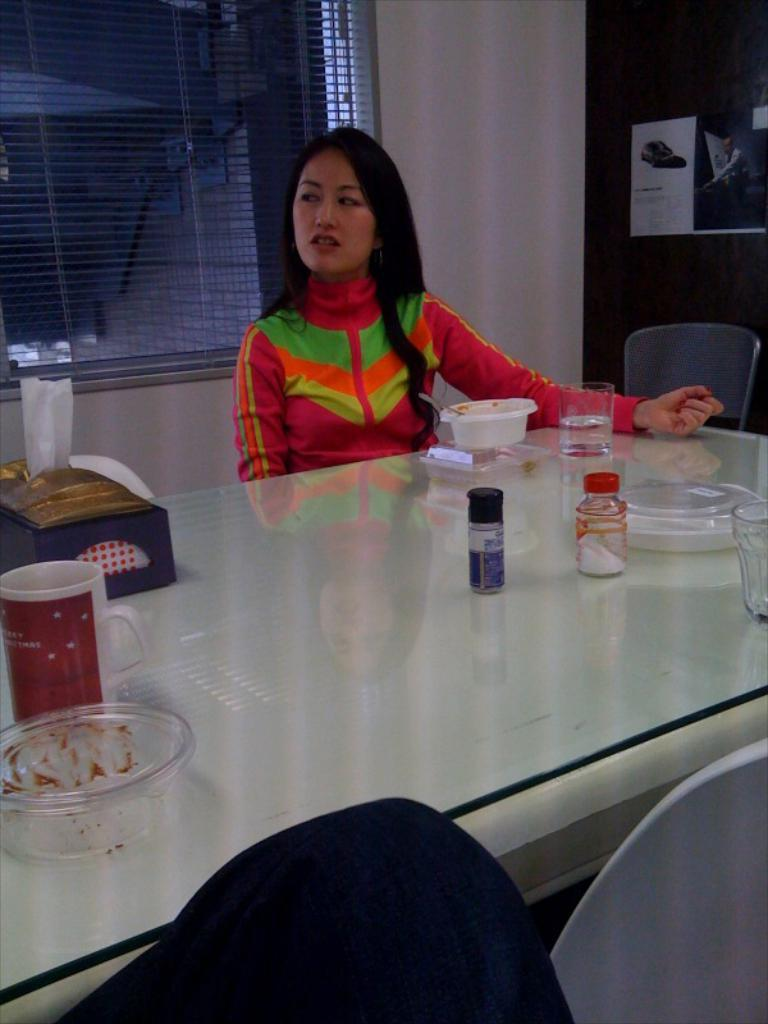Who is the main subject in the image? There is a woman in the image. Where is the woman located in the image? The woman is in the top center of the image. What type of table is present in the image? There is a glass table in the image. What items can be seen on the table? There is a cup, a plastic bowl, and a glass on the table. What type of cream can be seen on the bike in the image? There is no bike present in the image, and therefore no cream on a bike can be observed. 